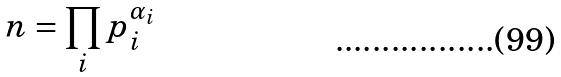Convert formula to latex. <formula><loc_0><loc_0><loc_500><loc_500>n = \prod _ { i } p _ { i } ^ { \alpha _ { i } }</formula> 